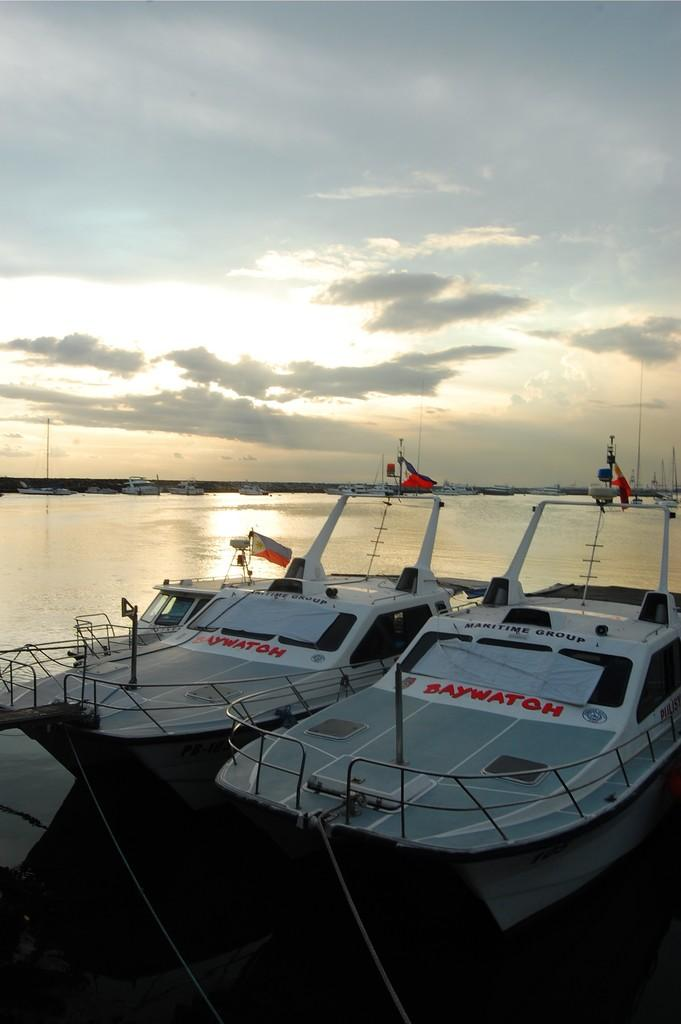What is located in the center of the image? There are boats and flags in the center of the image. What can be seen in the background of the image? There is a river and poles in the background of the image. What is visible at the top of the image? The sky is visible at the top of the image. What type of mint is growing near the river in the image? There is no mint present in the image; it features boats, flags, a river, poles, and the sky. 